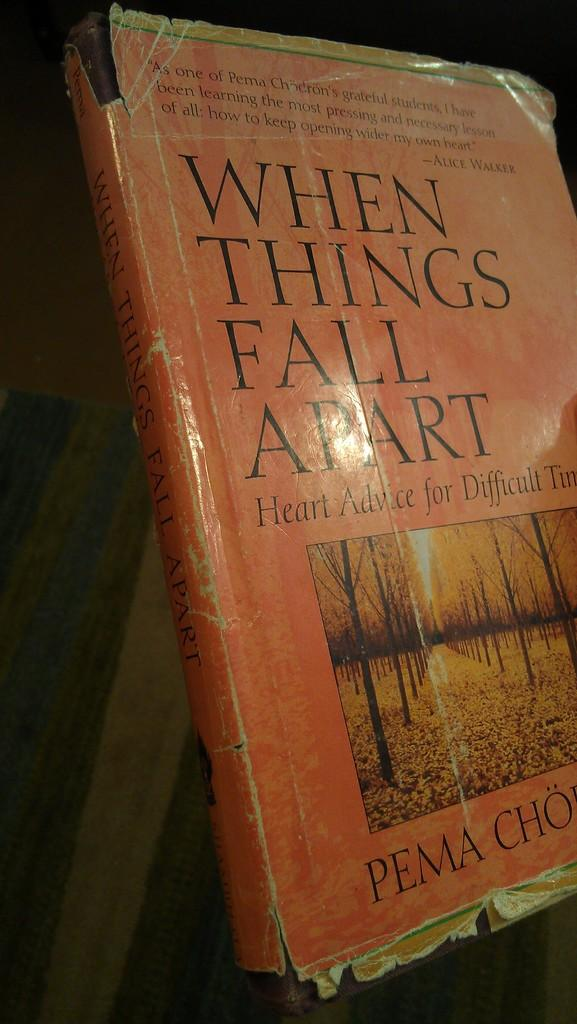<image>
Render a clear and concise summary of the photo. a book that is called when things fall apart 